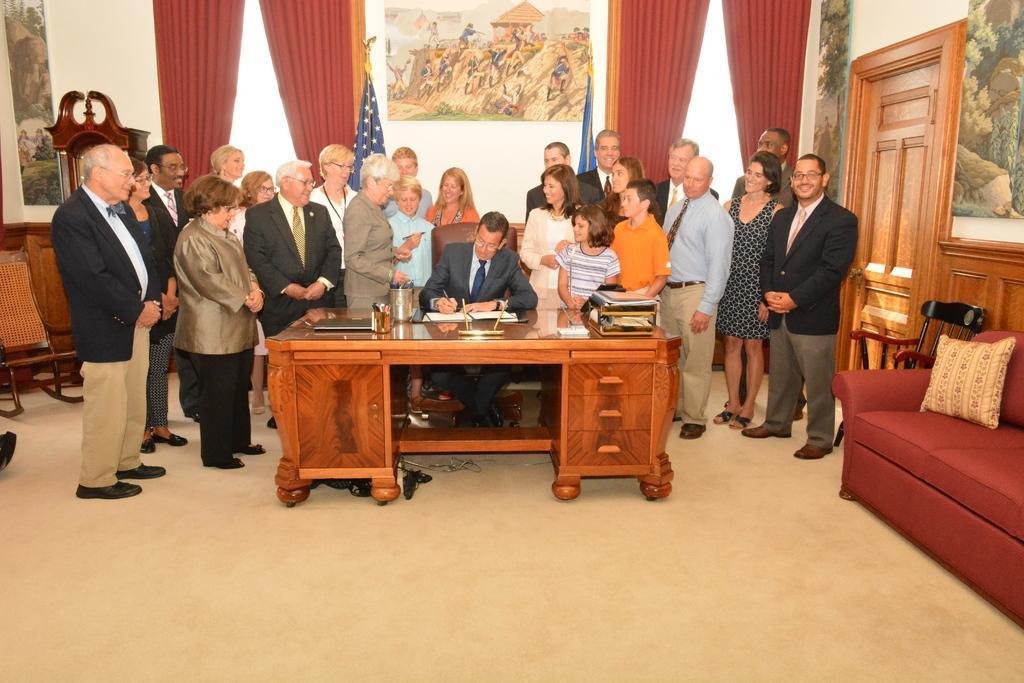Please provide a concise description of this image. In this image there are few persons standing. A person sitting on chair is wearing suit and tie is holding a pen and writing on a paper which is on table. At the right side there is door, canvas, chair, sofa having cushion in it. At the left side there is a chair. On top of the image there is a curtain, flags and a canvas hanged to the wall. 